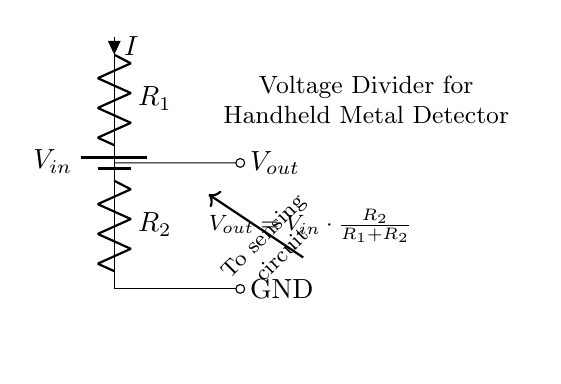What is the input voltage of the circuit? The input voltage, denoted as \( V_{in} \), is the voltage supplied by the battery, which is a key component of the circuit.
Answer: \( V_{in} \) What are the resistor values in the circuit? The resistors are labeled as \( R_1 \) and \( R_2 \). Their specific values are not given in the diagram, but they are critical for determining the output voltage.
Answer: \( R_1, R_2 \) What is the output voltage formula? The output voltage is calculated using the formula \( V_{out} = V_{in} \cdot \frac{R_2}{R_1 + R_2} \), which shows how the input voltage is divided based on the resistor values.
Answer: \( V_{out} = V_{in} \cdot \frac{R_2}{R_1 + R_2} \) What is the relationship between the output voltage and input voltage? The output voltage is a fraction of the input voltage, determined by the ratio of the resistors. This shows that the output voltage is less than the input voltage unless \( R_2 \) is significantly larger than \( R_1 \).
Answer: Output voltage is less than input voltage What happens if \( R_1 \) is increased? Increasing \( R_1 \) decreases the output voltage (\( V_{out} \)), since the ratio in the voltage divider formula changes, lowering \( V_{out} \) relative to \( V_{in} \).
Answer: Output voltage decreases How is current flowing in this circuit? The current \( I \) flows from the battery through \( R_1 \), then through \( R_2 \), before returning to the ground. This flow is essential for the operation of the voltage divider.
Answer: Flows from battery through \( R_1 \) and \( R_2 \) to ground What is the purpose of the voltage divider in the metal detector? The voltage divider creates a specific voltage level (\( V_{out} \)) needed to operate the sensing circuit of the metal detector effectively, allowing it to detect metal items.
Answer: To provide a specific voltage for the sensing circuit 